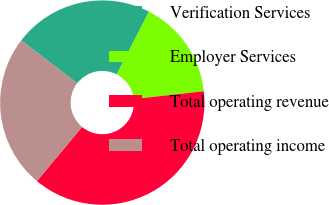Convert chart. <chart><loc_0><loc_0><loc_500><loc_500><pie_chart><fcel>Verification Services<fcel>Employer Services<fcel>Total operating revenue<fcel>Total operating income<nl><fcel>22.15%<fcel>15.67%<fcel>37.82%<fcel>24.36%<nl></chart> 